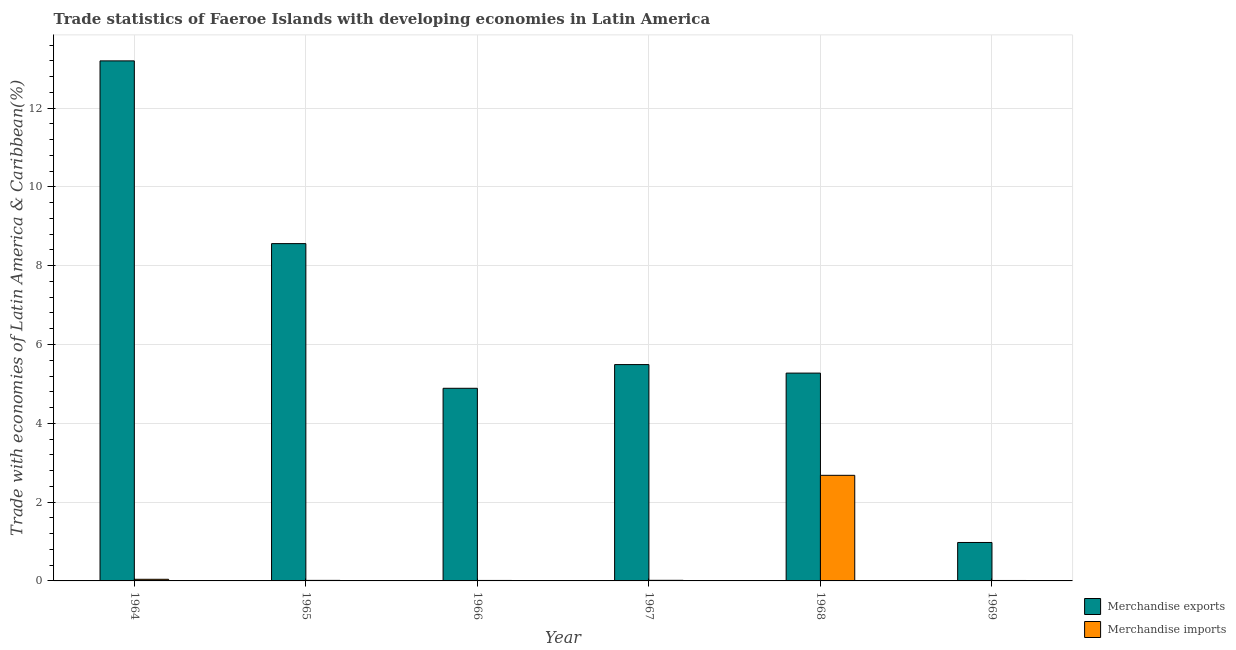Are the number of bars on each tick of the X-axis equal?
Ensure brevity in your answer.  Yes. How many bars are there on the 3rd tick from the left?
Provide a succinct answer. 2. What is the label of the 5th group of bars from the left?
Your response must be concise. 1968. What is the merchandise imports in 1966?
Your response must be concise. 0.01. Across all years, what is the maximum merchandise imports?
Give a very brief answer. 2.68. Across all years, what is the minimum merchandise exports?
Make the answer very short. 0.98. In which year was the merchandise exports maximum?
Offer a terse response. 1964. In which year was the merchandise imports minimum?
Make the answer very short. 1969. What is the total merchandise imports in the graph?
Offer a terse response. 2.77. What is the difference between the merchandise exports in 1965 and that in 1966?
Give a very brief answer. 3.67. What is the difference between the merchandise exports in 1969 and the merchandise imports in 1968?
Ensure brevity in your answer.  -4.3. What is the average merchandise exports per year?
Give a very brief answer. 6.4. What is the ratio of the merchandise imports in 1964 to that in 1967?
Keep it short and to the point. 2.68. Is the difference between the merchandise imports in 1965 and 1968 greater than the difference between the merchandise exports in 1965 and 1968?
Give a very brief answer. No. What is the difference between the highest and the second highest merchandise exports?
Offer a very short reply. 4.64. What is the difference between the highest and the lowest merchandise exports?
Your answer should be compact. 12.22. In how many years, is the merchandise exports greater than the average merchandise exports taken over all years?
Offer a terse response. 2. How many bars are there?
Your response must be concise. 12. What is the difference between two consecutive major ticks on the Y-axis?
Give a very brief answer. 2. Does the graph contain any zero values?
Your answer should be compact. No. Does the graph contain grids?
Your answer should be compact. Yes. How many legend labels are there?
Provide a succinct answer. 2. What is the title of the graph?
Give a very brief answer. Trade statistics of Faeroe Islands with developing economies in Latin America. Does "Netherlands" appear as one of the legend labels in the graph?
Offer a terse response. No. What is the label or title of the Y-axis?
Your response must be concise. Trade with economies of Latin America & Caribbean(%). What is the Trade with economies of Latin America & Caribbean(%) of Merchandise exports in 1964?
Provide a short and direct response. 13.2. What is the Trade with economies of Latin America & Caribbean(%) in Merchandise imports in 1964?
Ensure brevity in your answer.  0.04. What is the Trade with economies of Latin America & Caribbean(%) in Merchandise exports in 1965?
Offer a terse response. 8.56. What is the Trade with economies of Latin America & Caribbean(%) in Merchandise imports in 1965?
Make the answer very short. 0.01. What is the Trade with economies of Latin America & Caribbean(%) in Merchandise exports in 1966?
Offer a very short reply. 4.89. What is the Trade with economies of Latin America & Caribbean(%) in Merchandise imports in 1966?
Provide a succinct answer. 0.01. What is the Trade with economies of Latin America & Caribbean(%) of Merchandise exports in 1967?
Your response must be concise. 5.49. What is the Trade with economies of Latin America & Caribbean(%) of Merchandise imports in 1967?
Offer a very short reply. 0.02. What is the Trade with economies of Latin America & Caribbean(%) in Merchandise exports in 1968?
Your response must be concise. 5.27. What is the Trade with economies of Latin America & Caribbean(%) in Merchandise imports in 1968?
Keep it short and to the point. 2.68. What is the Trade with economies of Latin America & Caribbean(%) of Merchandise exports in 1969?
Make the answer very short. 0.98. What is the Trade with economies of Latin America & Caribbean(%) in Merchandise imports in 1969?
Ensure brevity in your answer.  0.01. Across all years, what is the maximum Trade with economies of Latin America & Caribbean(%) of Merchandise exports?
Your response must be concise. 13.2. Across all years, what is the maximum Trade with economies of Latin America & Caribbean(%) in Merchandise imports?
Your answer should be very brief. 2.68. Across all years, what is the minimum Trade with economies of Latin America & Caribbean(%) in Merchandise exports?
Provide a short and direct response. 0.98. Across all years, what is the minimum Trade with economies of Latin America & Caribbean(%) of Merchandise imports?
Provide a short and direct response. 0.01. What is the total Trade with economies of Latin America & Caribbean(%) of Merchandise exports in the graph?
Offer a very short reply. 38.39. What is the total Trade with economies of Latin America & Caribbean(%) in Merchandise imports in the graph?
Provide a short and direct response. 2.77. What is the difference between the Trade with economies of Latin America & Caribbean(%) of Merchandise exports in 1964 and that in 1965?
Your answer should be very brief. 4.64. What is the difference between the Trade with economies of Latin America & Caribbean(%) in Merchandise imports in 1964 and that in 1965?
Give a very brief answer. 0.03. What is the difference between the Trade with economies of Latin America & Caribbean(%) in Merchandise exports in 1964 and that in 1966?
Keep it short and to the point. 8.31. What is the difference between the Trade with economies of Latin America & Caribbean(%) in Merchandise imports in 1964 and that in 1966?
Your response must be concise. 0.03. What is the difference between the Trade with economies of Latin America & Caribbean(%) in Merchandise exports in 1964 and that in 1967?
Your answer should be very brief. 7.71. What is the difference between the Trade with economies of Latin America & Caribbean(%) of Merchandise imports in 1964 and that in 1967?
Provide a succinct answer. 0.03. What is the difference between the Trade with economies of Latin America & Caribbean(%) in Merchandise exports in 1964 and that in 1968?
Provide a succinct answer. 7.92. What is the difference between the Trade with economies of Latin America & Caribbean(%) of Merchandise imports in 1964 and that in 1968?
Provide a short and direct response. -2.64. What is the difference between the Trade with economies of Latin America & Caribbean(%) in Merchandise exports in 1964 and that in 1969?
Your answer should be compact. 12.22. What is the difference between the Trade with economies of Latin America & Caribbean(%) of Merchandise imports in 1964 and that in 1969?
Ensure brevity in your answer.  0.03. What is the difference between the Trade with economies of Latin America & Caribbean(%) of Merchandise exports in 1965 and that in 1966?
Provide a short and direct response. 3.67. What is the difference between the Trade with economies of Latin America & Caribbean(%) of Merchandise imports in 1965 and that in 1966?
Your response must be concise. 0. What is the difference between the Trade with economies of Latin America & Caribbean(%) of Merchandise exports in 1965 and that in 1967?
Your response must be concise. 3.07. What is the difference between the Trade with economies of Latin America & Caribbean(%) of Merchandise imports in 1965 and that in 1967?
Offer a very short reply. -0. What is the difference between the Trade with economies of Latin America & Caribbean(%) of Merchandise exports in 1965 and that in 1968?
Offer a very short reply. 3.29. What is the difference between the Trade with economies of Latin America & Caribbean(%) of Merchandise imports in 1965 and that in 1968?
Offer a very short reply. -2.67. What is the difference between the Trade with economies of Latin America & Caribbean(%) of Merchandise exports in 1965 and that in 1969?
Your response must be concise. 7.58. What is the difference between the Trade with economies of Latin America & Caribbean(%) in Merchandise imports in 1965 and that in 1969?
Keep it short and to the point. 0. What is the difference between the Trade with economies of Latin America & Caribbean(%) in Merchandise exports in 1966 and that in 1967?
Offer a terse response. -0.6. What is the difference between the Trade with economies of Latin America & Caribbean(%) of Merchandise imports in 1966 and that in 1967?
Your answer should be compact. -0. What is the difference between the Trade with economies of Latin America & Caribbean(%) of Merchandise exports in 1966 and that in 1968?
Provide a short and direct response. -0.39. What is the difference between the Trade with economies of Latin America & Caribbean(%) of Merchandise imports in 1966 and that in 1968?
Make the answer very short. -2.67. What is the difference between the Trade with economies of Latin America & Caribbean(%) of Merchandise exports in 1966 and that in 1969?
Keep it short and to the point. 3.91. What is the difference between the Trade with economies of Latin America & Caribbean(%) of Merchandise imports in 1966 and that in 1969?
Your response must be concise. 0. What is the difference between the Trade with economies of Latin America & Caribbean(%) in Merchandise exports in 1967 and that in 1968?
Give a very brief answer. 0.22. What is the difference between the Trade with economies of Latin America & Caribbean(%) in Merchandise imports in 1967 and that in 1968?
Provide a short and direct response. -2.66. What is the difference between the Trade with economies of Latin America & Caribbean(%) in Merchandise exports in 1967 and that in 1969?
Make the answer very short. 4.51. What is the difference between the Trade with economies of Latin America & Caribbean(%) in Merchandise imports in 1967 and that in 1969?
Keep it short and to the point. 0. What is the difference between the Trade with economies of Latin America & Caribbean(%) in Merchandise exports in 1968 and that in 1969?
Your answer should be compact. 4.3. What is the difference between the Trade with economies of Latin America & Caribbean(%) of Merchandise imports in 1968 and that in 1969?
Your answer should be compact. 2.67. What is the difference between the Trade with economies of Latin America & Caribbean(%) in Merchandise exports in 1964 and the Trade with economies of Latin America & Caribbean(%) in Merchandise imports in 1965?
Provide a succinct answer. 13.18. What is the difference between the Trade with economies of Latin America & Caribbean(%) of Merchandise exports in 1964 and the Trade with economies of Latin America & Caribbean(%) of Merchandise imports in 1966?
Provide a short and direct response. 13.19. What is the difference between the Trade with economies of Latin America & Caribbean(%) in Merchandise exports in 1964 and the Trade with economies of Latin America & Caribbean(%) in Merchandise imports in 1967?
Offer a very short reply. 13.18. What is the difference between the Trade with economies of Latin America & Caribbean(%) in Merchandise exports in 1964 and the Trade with economies of Latin America & Caribbean(%) in Merchandise imports in 1968?
Keep it short and to the point. 10.52. What is the difference between the Trade with economies of Latin America & Caribbean(%) of Merchandise exports in 1964 and the Trade with economies of Latin America & Caribbean(%) of Merchandise imports in 1969?
Your answer should be compact. 13.19. What is the difference between the Trade with economies of Latin America & Caribbean(%) in Merchandise exports in 1965 and the Trade with economies of Latin America & Caribbean(%) in Merchandise imports in 1966?
Your answer should be very brief. 8.55. What is the difference between the Trade with economies of Latin America & Caribbean(%) in Merchandise exports in 1965 and the Trade with economies of Latin America & Caribbean(%) in Merchandise imports in 1967?
Provide a short and direct response. 8.54. What is the difference between the Trade with economies of Latin America & Caribbean(%) in Merchandise exports in 1965 and the Trade with economies of Latin America & Caribbean(%) in Merchandise imports in 1968?
Give a very brief answer. 5.88. What is the difference between the Trade with economies of Latin America & Caribbean(%) in Merchandise exports in 1965 and the Trade with economies of Latin America & Caribbean(%) in Merchandise imports in 1969?
Make the answer very short. 8.55. What is the difference between the Trade with economies of Latin America & Caribbean(%) of Merchandise exports in 1966 and the Trade with economies of Latin America & Caribbean(%) of Merchandise imports in 1967?
Offer a terse response. 4.87. What is the difference between the Trade with economies of Latin America & Caribbean(%) of Merchandise exports in 1966 and the Trade with economies of Latin America & Caribbean(%) of Merchandise imports in 1968?
Give a very brief answer. 2.21. What is the difference between the Trade with economies of Latin America & Caribbean(%) in Merchandise exports in 1966 and the Trade with economies of Latin America & Caribbean(%) in Merchandise imports in 1969?
Your answer should be very brief. 4.88. What is the difference between the Trade with economies of Latin America & Caribbean(%) of Merchandise exports in 1967 and the Trade with economies of Latin America & Caribbean(%) of Merchandise imports in 1968?
Provide a succinct answer. 2.81. What is the difference between the Trade with economies of Latin America & Caribbean(%) in Merchandise exports in 1967 and the Trade with economies of Latin America & Caribbean(%) in Merchandise imports in 1969?
Offer a terse response. 5.48. What is the difference between the Trade with economies of Latin America & Caribbean(%) of Merchandise exports in 1968 and the Trade with economies of Latin America & Caribbean(%) of Merchandise imports in 1969?
Ensure brevity in your answer.  5.26. What is the average Trade with economies of Latin America & Caribbean(%) in Merchandise exports per year?
Your response must be concise. 6.4. What is the average Trade with economies of Latin America & Caribbean(%) in Merchandise imports per year?
Offer a terse response. 0.46. In the year 1964, what is the difference between the Trade with economies of Latin America & Caribbean(%) in Merchandise exports and Trade with economies of Latin America & Caribbean(%) in Merchandise imports?
Give a very brief answer. 13.16. In the year 1965, what is the difference between the Trade with economies of Latin America & Caribbean(%) in Merchandise exports and Trade with economies of Latin America & Caribbean(%) in Merchandise imports?
Your answer should be very brief. 8.55. In the year 1966, what is the difference between the Trade with economies of Latin America & Caribbean(%) of Merchandise exports and Trade with economies of Latin America & Caribbean(%) of Merchandise imports?
Offer a very short reply. 4.88. In the year 1967, what is the difference between the Trade with economies of Latin America & Caribbean(%) in Merchandise exports and Trade with economies of Latin America & Caribbean(%) in Merchandise imports?
Your answer should be very brief. 5.47. In the year 1968, what is the difference between the Trade with economies of Latin America & Caribbean(%) in Merchandise exports and Trade with economies of Latin America & Caribbean(%) in Merchandise imports?
Provide a succinct answer. 2.59. What is the ratio of the Trade with economies of Latin America & Caribbean(%) of Merchandise exports in 1964 to that in 1965?
Make the answer very short. 1.54. What is the ratio of the Trade with economies of Latin America & Caribbean(%) in Merchandise imports in 1964 to that in 1965?
Keep it short and to the point. 3. What is the ratio of the Trade with economies of Latin America & Caribbean(%) in Merchandise exports in 1964 to that in 1966?
Ensure brevity in your answer.  2.7. What is the ratio of the Trade with economies of Latin America & Caribbean(%) in Merchandise imports in 1964 to that in 1966?
Your answer should be compact. 3.43. What is the ratio of the Trade with economies of Latin America & Caribbean(%) of Merchandise exports in 1964 to that in 1967?
Your answer should be very brief. 2.4. What is the ratio of the Trade with economies of Latin America & Caribbean(%) in Merchandise imports in 1964 to that in 1967?
Give a very brief answer. 2.68. What is the ratio of the Trade with economies of Latin America & Caribbean(%) of Merchandise exports in 1964 to that in 1968?
Provide a succinct answer. 2.5. What is the ratio of the Trade with economies of Latin America & Caribbean(%) of Merchandise imports in 1964 to that in 1968?
Your answer should be compact. 0.02. What is the ratio of the Trade with economies of Latin America & Caribbean(%) of Merchandise exports in 1964 to that in 1969?
Your response must be concise. 13.53. What is the ratio of the Trade with economies of Latin America & Caribbean(%) in Merchandise imports in 1964 to that in 1969?
Your answer should be very brief. 3.61. What is the ratio of the Trade with economies of Latin America & Caribbean(%) in Merchandise exports in 1965 to that in 1966?
Offer a terse response. 1.75. What is the ratio of the Trade with economies of Latin America & Caribbean(%) in Merchandise imports in 1965 to that in 1966?
Offer a very short reply. 1.14. What is the ratio of the Trade with economies of Latin America & Caribbean(%) in Merchandise exports in 1965 to that in 1967?
Provide a succinct answer. 1.56. What is the ratio of the Trade with economies of Latin America & Caribbean(%) of Merchandise imports in 1965 to that in 1967?
Provide a short and direct response. 0.9. What is the ratio of the Trade with economies of Latin America & Caribbean(%) of Merchandise exports in 1965 to that in 1968?
Keep it short and to the point. 1.62. What is the ratio of the Trade with economies of Latin America & Caribbean(%) in Merchandise imports in 1965 to that in 1968?
Offer a terse response. 0.01. What is the ratio of the Trade with economies of Latin America & Caribbean(%) of Merchandise exports in 1965 to that in 1969?
Make the answer very short. 8.77. What is the ratio of the Trade with economies of Latin America & Caribbean(%) of Merchandise imports in 1965 to that in 1969?
Make the answer very short. 1.2. What is the ratio of the Trade with economies of Latin America & Caribbean(%) of Merchandise exports in 1966 to that in 1967?
Offer a terse response. 0.89. What is the ratio of the Trade with economies of Latin America & Caribbean(%) of Merchandise imports in 1966 to that in 1967?
Your answer should be compact. 0.78. What is the ratio of the Trade with economies of Latin America & Caribbean(%) in Merchandise exports in 1966 to that in 1968?
Provide a short and direct response. 0.93. What is the ratio of the Trade with economies of Latin America & Caribbean(%) in Merchandise imports in 1966 to that in 1968?
Provide a short and direct response. 0. What is the ratio of the Trade with economies of Latin America & Caribbean(%) in Merchandise exports in 1966 to that in 1969?
Ensure brevity in your answer.  5.01. What is the ratio of the Trade with economies of Latin America & Caribbean(%) in Merchandise imports in 1966 to that in 1969?
Ensure brevity in your answer.  1.05. What is the ratio of the Trade with economies of Latin America & Caribbean(%) of Merchandise exports in 1967 to that in 1968?
Keep it short and to the point. 1.04. What is the ratio of the Trade with economies of Latin America & Caribbean(%) in Merchandise imports in 1967 to that in 1968?
Your answer should be compact. 0.01. What is the ratio of the Trade with economies of Latin America & Caribbean(%) of Merchandise exports in 1967 to that in 1969?
Give a very brief answer. 5.63. What is the ratio of the Trade with economies of Latin America & Caribbean(%) in Merchandise imports in 1967 to that in 1969?
Make the answer very short. 1.34. What is the ratio of the Trade with economies of Latin America & Caribbean(%) in Merchandise exports in 1968 to that in 1969?
Provide a short and direct response. 5.41. What is the ratio of the Trade with economies of Latin America & Caribbean(%) in Merchandise imports in 1968 to that in 1969?
Your answer should be very brief. 233.91. What is the difference between the highest and the second highest Trade with economies of Latin America & Caribbean(%) of Merchandise exports?
Your answer should be compact. 4.64. What is the difference between the highest and the second highest Trade with economies of Latin America & Caribbean(%) of Merchandise imports?
Keep it short and to the point. 2.64. What is the difference between the highest and the lowest Trade with economies of Latin America & Caribbean(%) of Merchandise exports?
Give a very brief answer. 12.22. What is the difference between the highest and the lowest Trade with economies of Latin America & Caribbean(%) of Merchandise imports?
Your answer should be very brief. 2.67. 